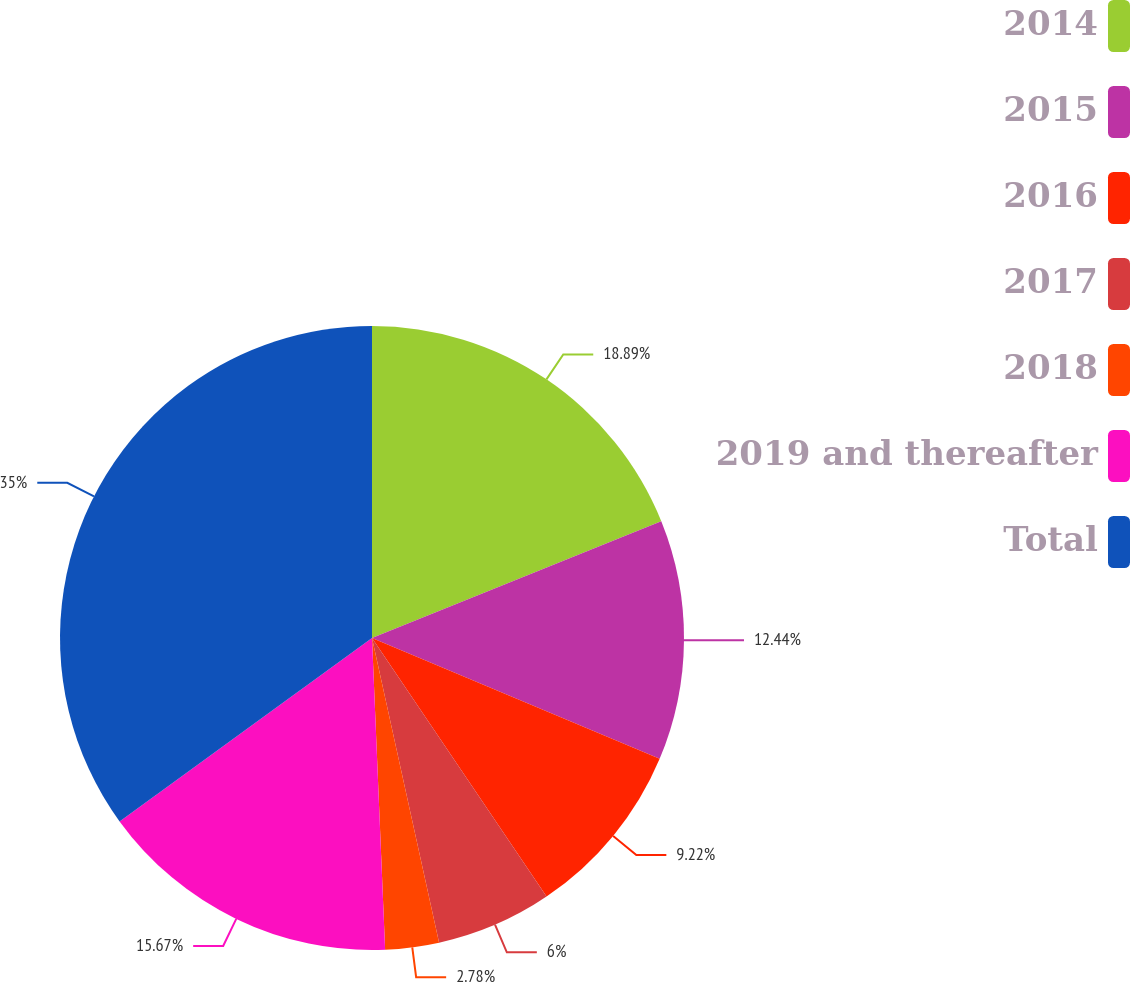<chart> <loc_0><loc_0><loc_500><loc_500><pie_chart><fcel>2014<fcel>2015<fcel>2016<fcel>2017<fcel>2018<fcel>2019 and thereafter<fcel>Total<nl><fcel>18.89%<fcel>12.44%<fcel>9.22%<fcel>6.0%<fcel>2.78%<fcel>15.67%<fcel>35.0%<nl></chart> 